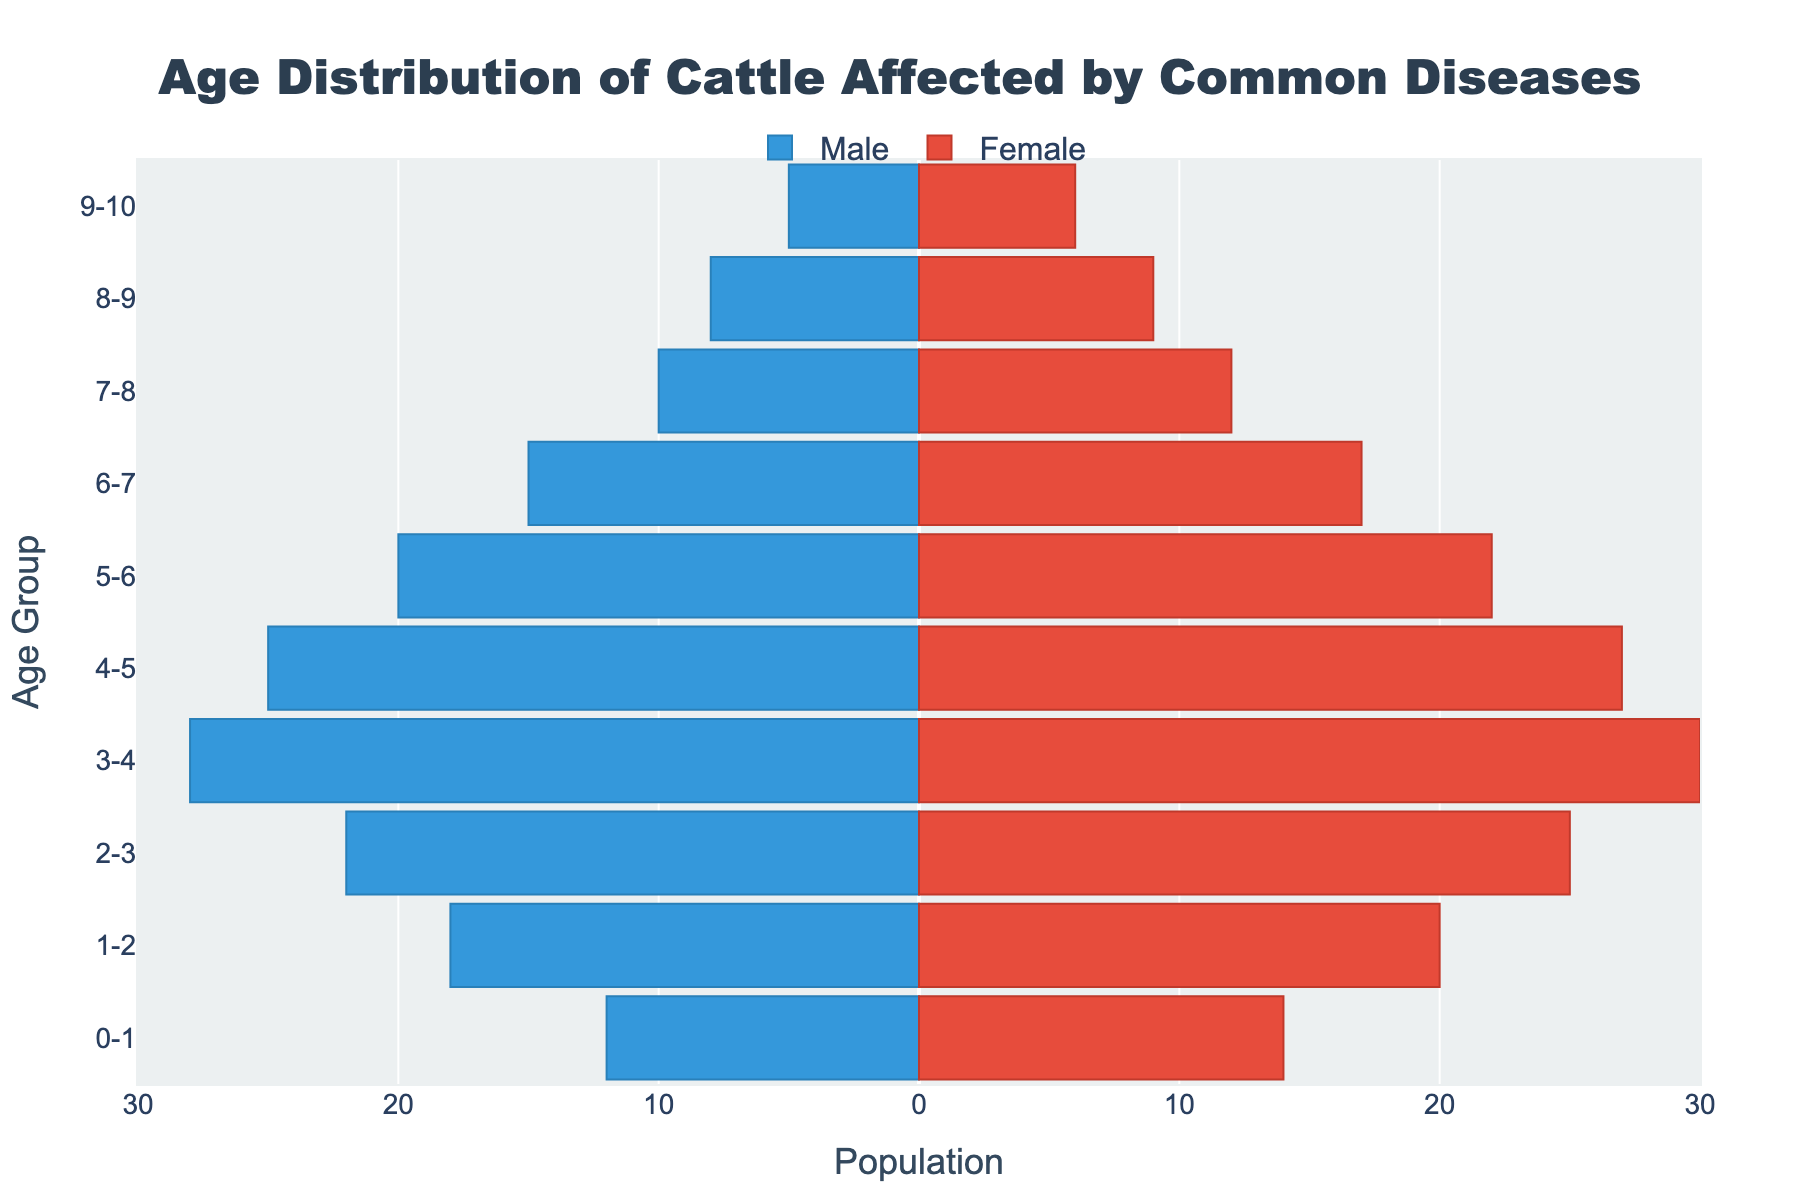What is the title of the figure? The title is located at the top center of the figure and usually includes a description of what the figure represents.
Answer: Age Distribution of Cattle Affected by Common Diseases Which age group has the highest number of affected male cattle? To determine this, look for the bar that extends the furthest to the left (as male values are negative) on the horizontal axis and check the corresponding age group on the vertical axis.
Answer: 3-4 What disease affects the highest number of female cattle in the age group 2-3? Locate the bar for the female population in the age group 2-3 and refer to the hover information to identify the disease.
Answer: Mastitis What is the total number of cattle (male and female) affected in the age group 4-5? Sum the values of male and female cattle in the age group 4-5, keeping in mind that male values are negative. So, (25 + 27) = 52.
Answer: 52 Which age group is least affected by Milk Fever in terms of number of cattle (both male and female)? Identify the age group that corresponds to Milk Fever and note the combined length of the bars for both genders.
Answer: 7-8 Compare the number of male and female cattle affected by Bovine Viral Diarrhea. Which gender has more affected cattle and by how much? Check the values for both males and females in the age group 1-2 and find the difference. For males, it’s 18 and for females, it’s 20. So, females have (20 - 18) = 2 more affected individuals.
Answer: Females, by 2 How many more female cattle are affected by Foot Rot compared to Johne's Disease? Determine the number of females in the age group 3-4 (Foot Rot) and age group 5-6 (Johne's Disease), then compute the difference. Foot Rot affects 30 females, and Johne's Disease affects 22 females. So, 30 - 22 = 8.
Answer: 8 Which age group has the smallest difference in the number of male and female cattle affected by any disease? Calculate the absolute differences for each age group and identify the smallest one.
Answer: 0-1 (2 difference) Identify the age group with the most balanced (almost equal) number of male and female cattle affected. What disease is most prevalent in this age group? Look for the age group where the male and female bars are nearly equal. Check the related disease through hover information.
Answer: 8-9, Ketosis 